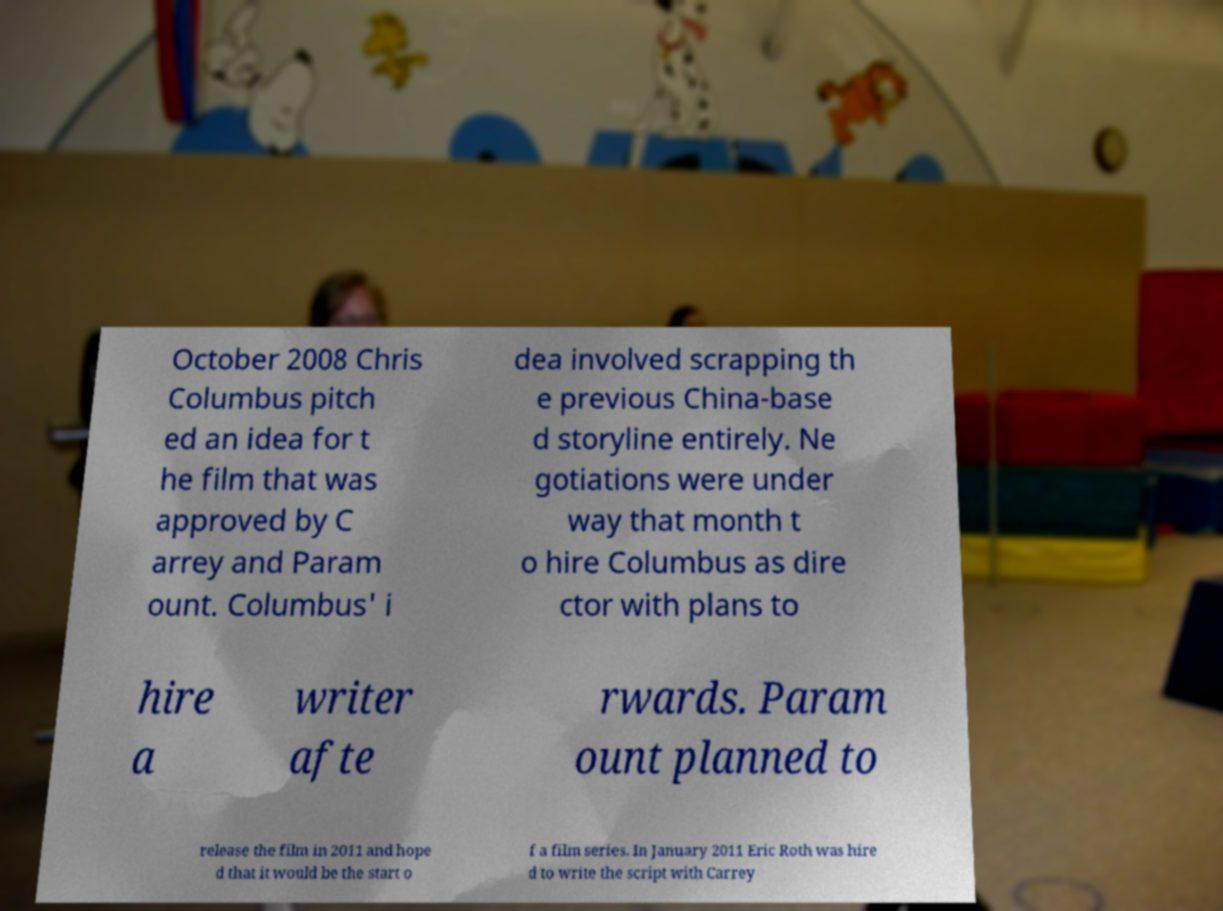Please identify and transcribe the text found in this image. October 2008 Chris Columbus pitch ed an idea for t he film that was approved by C arrey and Param ount. Columbus' i dea involved scrapping th e previous China-base d storyline entirely. Ne gotiations were under way that month t o hire Columbus as dire ctor with plans to hire a writer afte rwards. Param ount planned to release the film in 2011 and hope d that it would be the start o f a film series. In January 2011 Eric Roth was hire d to write the script with Carrey 